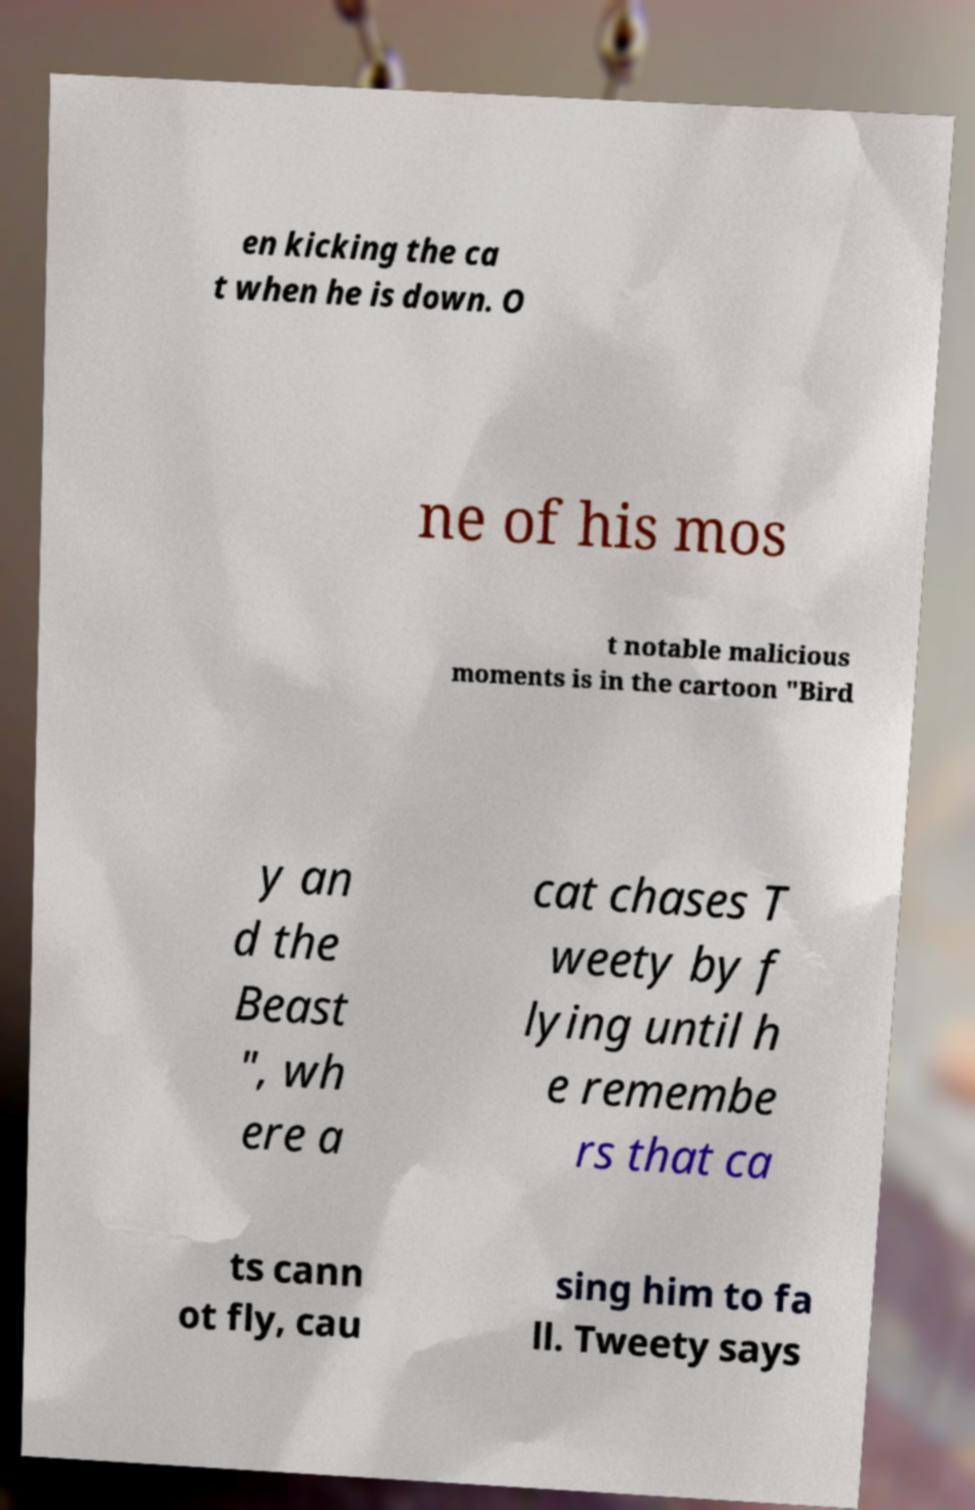Could you extract and type out the text from this image? en kicking the ca t when he is down. O ne of his mos t notable malicious moments is in the cartoon "Bird y an d the Beast ", wh ere a cat chases T weety by f lying until h e remembe rs that ca ts cann ot fly, cau sing him to fa ll. Tweety says 